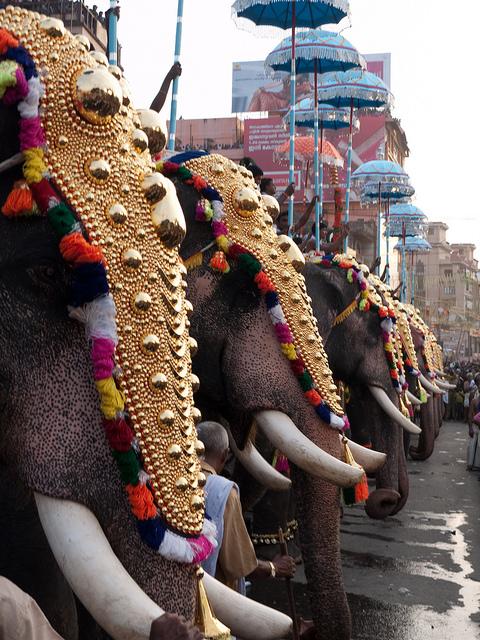Are these elephants dressed up?
Be succinct. Yes. How many elephants are there?
Answer briefly. 6. Is it daytime?
Write a very short answer. Yes. Are people on the top of the elephant?
Quick response, please. Yes. 